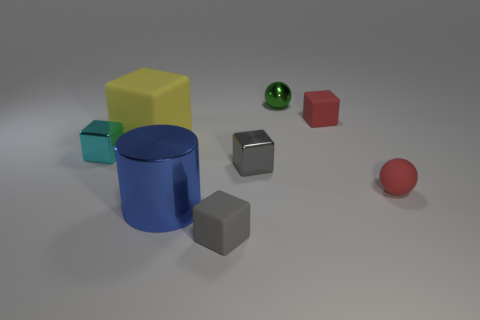Subtract 1 cubes. How many cubes are left? 4 Subtract all cyan cubes. How many cubes are left? 4 Subtract all small gray metal cubes. How many cubes are left? 4 Subtract all red cubes. Subtract all gray cylinders. How many cubes are left? 4 Add 1 big matte objects. How many objects exist? 9 Subtract all cylinders. How many objects are left? 7 Subtract all tiny metallic objects. Subtract all green metallic things. How many objects are left? 4 Add 6 big rubber cubes. How many big rubber cubes are left? 7 Add 1 large yellow matte cubes. How many large yellow matte cubes exist? 2 Subtract 1 cyan cubes. How many objects are left? 7 